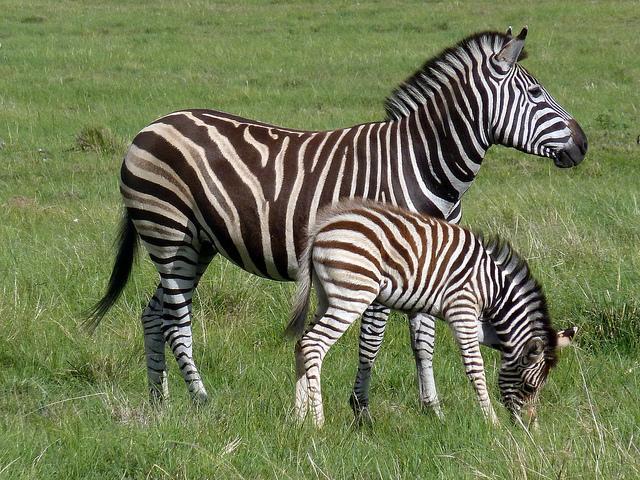How many ears can you see?
Give a very brief answer. 4. How many zebras are in the picture?
Give a very brief answer. 2. 